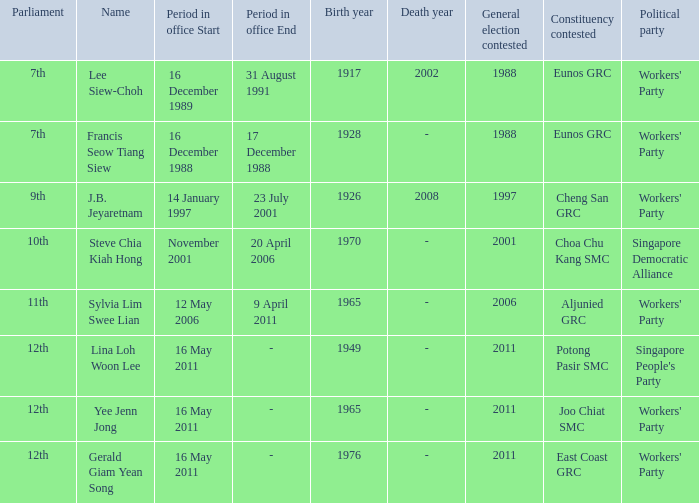When was the 11th parliament in session? 12 May2006– 9 April 2011. 